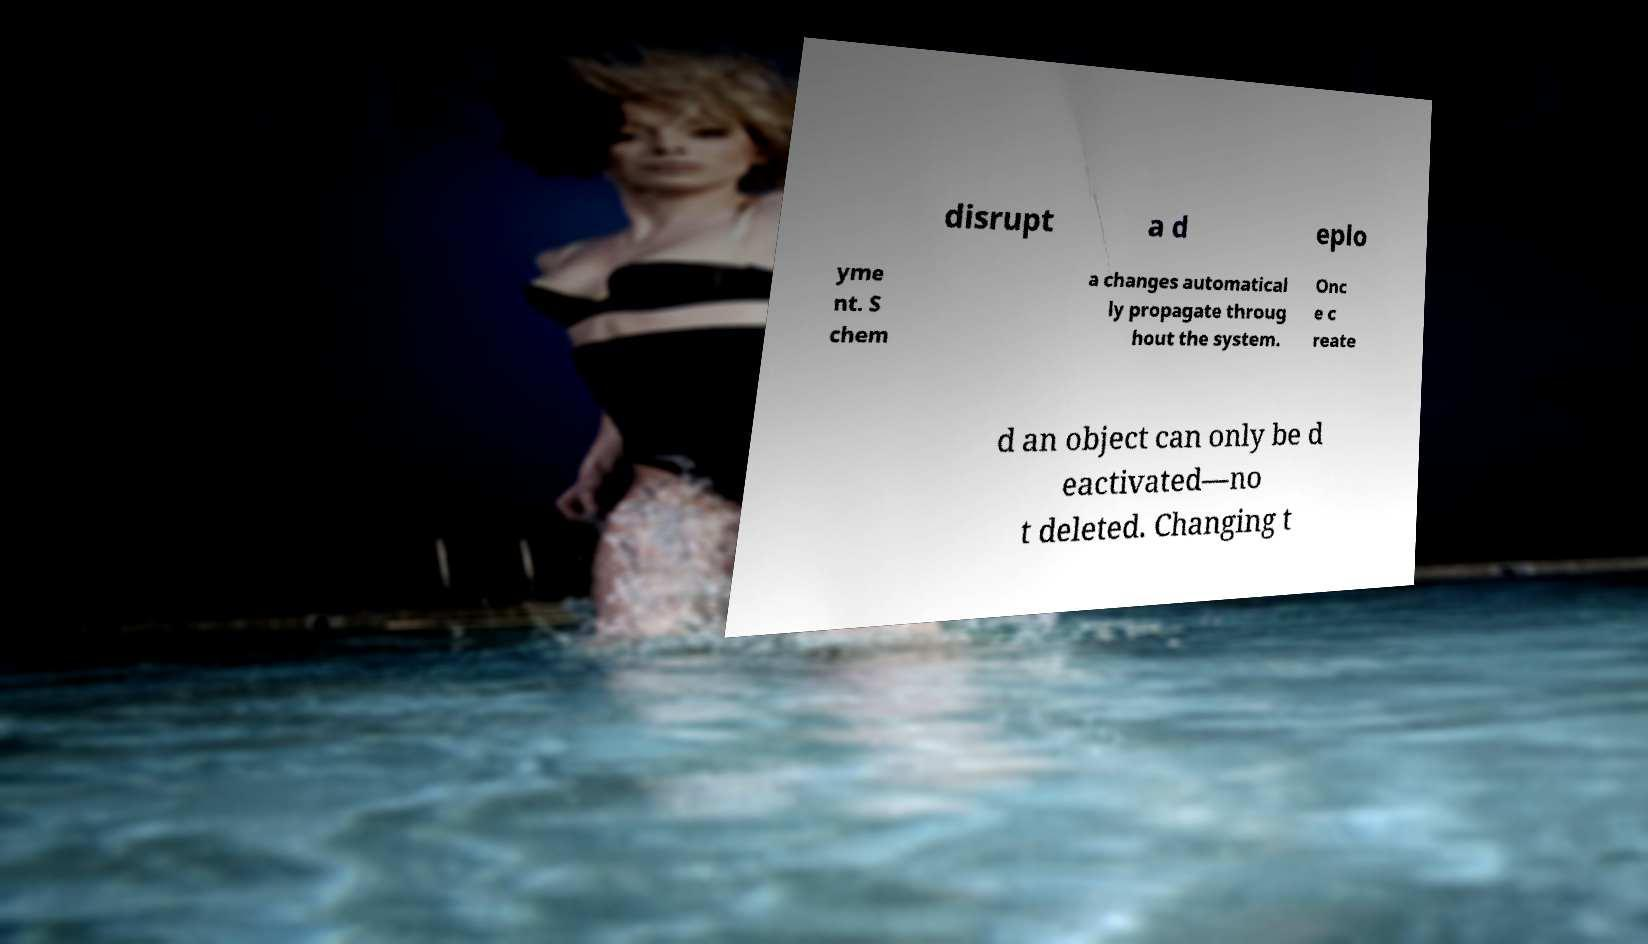What messages or text are displayed in this image? I need them in a readable, typed format. disrupt a d eplo yme nt. S chem a changes automatical ly propagate throug hout the system. Onc e c reate d an object can only be d eactivated—no t deleted. Changing t 